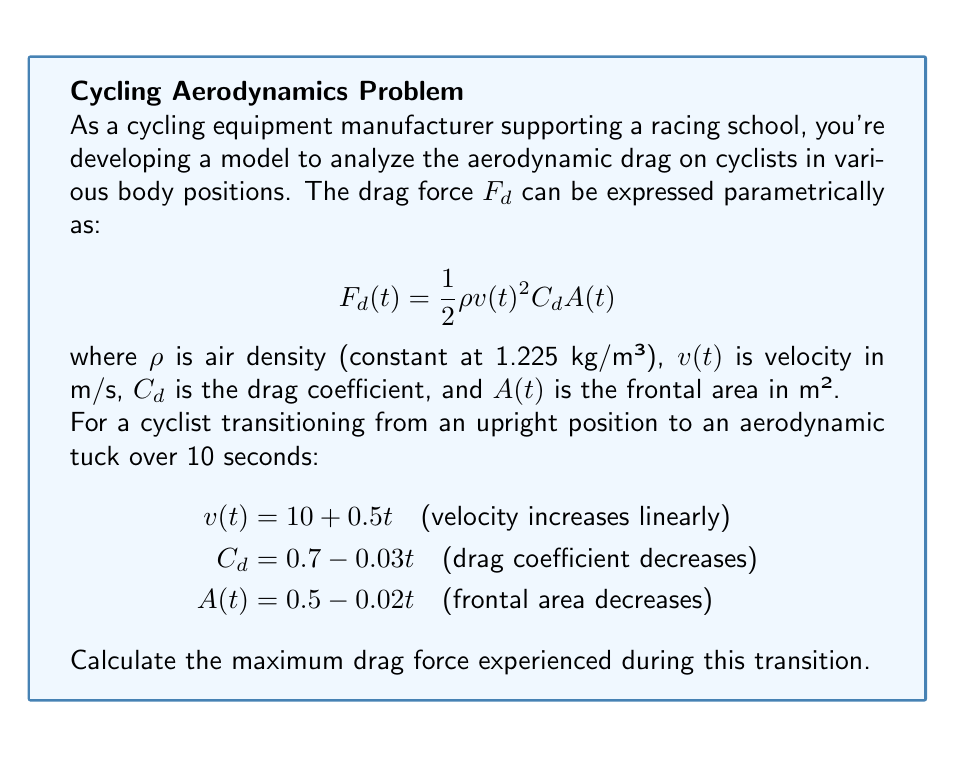Teach me how to tackle this problem. To find the maximum drag force, we need to follow these steps:

1) First, let's substitute the given functions into the drag force equation:

   $$F_d(t) = \frac{1}{2} (1.225) (10 + 0.5t)^2 (0.7 - 0.03t) (0.5 - 0.02t)$$

2) Expand this equation:

   $$F_d(t) = 0.6125 (100 + 10t + 0.25t^2) (0.35 - 0.025t + 0.0006t^2)$$

3) To find the maximum, we need to differentiate $F_d(t)$ with respect to $t$ and set it to zero:

   $$\frac{dF_d}{dt} = 0.6125 [(10 + 0.5t)(0.35 - 0.025t + 0.0006t^2) + (100 + 10t + 0.25t^2)(-0.025 + 0.0012t)]$$

4) Setting this equal to zero and solving for $t$ is complex algebraically. We can use numerical methods or a graphing calculator to find that the maximum occurs at approximately $t = 3.8$ seconds.

5) Substitute this value back into the original equation for $F_d(t)$:

   $$F_d(3.8) = \frac{1}{2} (1.225) (10 + 0.5(3.8))^2 (0.7 - 0.03(3.8)) (0.5 - 0.02(3.8))$$

6) Calculate this value:

   $$F_d(3.8) \approx 44.7 N$$

Thus, the maximum drag force occurs at about 3.8 seconds into the transition and is approximately 44.7 N.
Answer: 44.7 N 